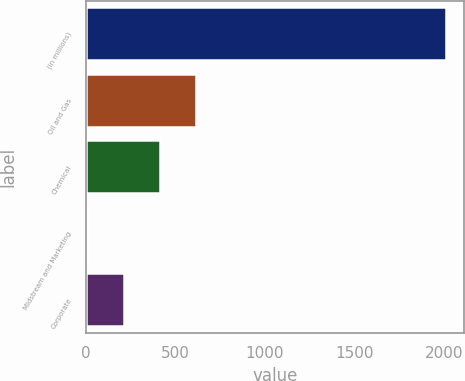Convert chart. <chart><loc_0><loc_0><loc_500><loc_500><bar_chart><fcel>(in millions)<fcel>Oil and Gas<fcel>Chemical<fcel>Midstream and Marketing<fcel>Corporate<nl><fcel>2012<fcel>612.7<fcel>412.8<fcel>13<fcel>212.9<nl></chart> 